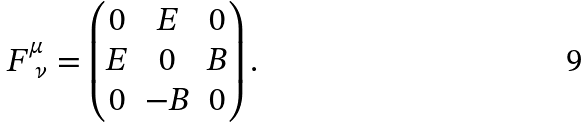Convert formula to latex. <formula><loc_0><loc_0><loc_500><loc_500>& F ^ { \mu } _ { \ \nu } = \begin{pmatrix} 0 & E & 0 \\ E & 0 & B \\ 0 & - B & 0 \end{pmatrix} .</formula> 